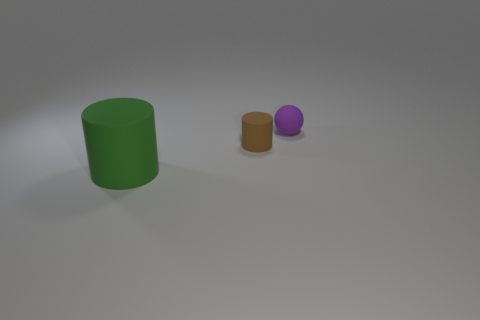What is the shape of the large thing that is made of the same material as the brown cylinder?
Give a very brief answer. Cylinder. Is there any other thing that has the same shape as the brown thing?
Make the answer very short. Yes. Is the thing behind the brown object made of the same material as the tiny cylinder?
Offer a terse response. Yes. There is a tiny object right of the tiny brown matte cylinder; what is it made of?
Provide a short and direct response. Rubber. What is the size of the object that is on the right side of the small matte object that is left of the small purple matte sphere?
Your response must be concise. Small. How many matte balls are the same size as the brown rubber thing?
Your answer should be very brief. 1. Does the tiny thing in front of the tiny matte sphere have the same color as the rubber object on the left side of the tiny brown rubber object?
Give a very brief answer. No. There is a small purple rubber object; are there any spheres behind it?
Provide a succinct answer. No. There is a object that is both right of the green object and in front of the small purple rubber sphere; what is its color?
Provide a succinct answer. Brown. Is there another small ball of the same color as the tiny ball?
Your response must be concise. No. 